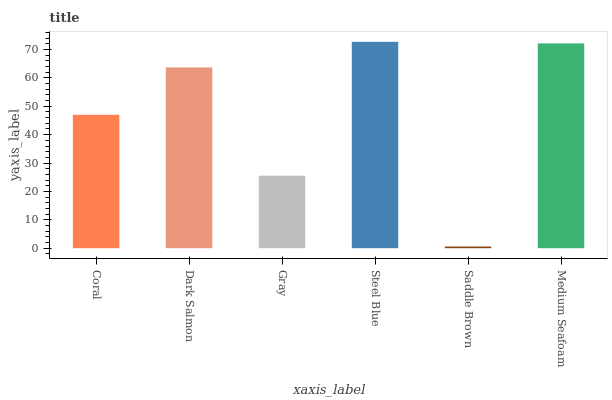Is Saddle Brown the minimum?
Answer yes or no. Yes. Is Steel Blue the maximum?
Answer yes or no. Yes. Is Dark Salmon the minimum?
Answer yes or no. No. Is Dark Salmon the maximum?
Answer yes or no. No. Is Dark Salmon greater than Coral?
Answer yes or no. Yes. Is Coral less than Dark Salmon?
Answer yes or no. Yes. Is Coral greater than Dark Salmon?
Answer yes or no. No. Is Dark Salmon less than Coral?
Answer yes or no. No. Is Dark Salmon the high median?
Answer yes or no. Yes. Is Coral the low median?
Answer yes or no. Yes. Is Medium Seafoam the high median?
Answer yes or no. No. Is Gray the low median?
Answer yes or no. No. 